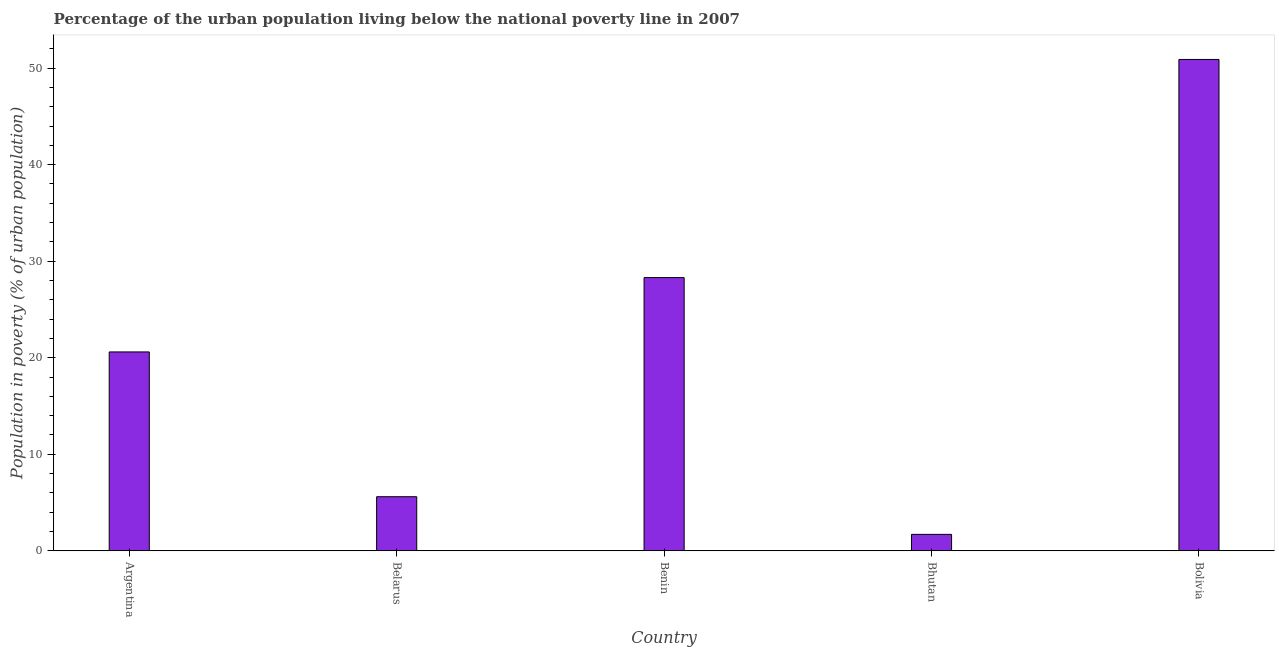What is the title of the graph?
Ensure brevity in your answer.  Percentage of the urban population living below the national poverty line in 2007. What is the label or title of the Y-axis?
Your response must be concise. Population in poverty (% of urban population). Across all countries, what is the maximum percentage of urban population living below poverty line?
Your answer should be very brief. 50.9. Across all countries, what is the minimum percentage of urban population living below poverty line?
Keep it short and to the point. 1.7. In which country was the percentage of urban population living below poverty line minimum?
Offer a terse response. Bhutan. What is the sum of the percentage of urban population living below poverty line?
Offer a very short reply. 107.1. What is the average percentage of urban population living below poverty line per country?
Make the answer very short. 21.42. What is the median percentage of urban population living below poverty line?
Make the answer very short. 20.6. What is the ratio of the percentage of urban population living below poverty line in Bhutan to that in Bolivia?
Offer a very short reply. 0.03. Is the percentage of urban population living below poverty line in Belarus less than that in Benin?
Make the answer very short. Yes. What is the difference between the highest and the second highest percentage of urban population living below poverty line?
Make the answer very short. 22.6. Is the sum of the percentage of urban population living below poverty line in Benin and Bhutan greater than the maximum percentage of urban population living below poverty line across all countries?
Your response must be concise. No. What is the difference between the highest and the lowest percentage of urban population living below poverty line?
Your answer should be very brief. 49.2. How many bars are there?
Your response must be concise. 5. Are all the bars in the graph horizontal?
Your answer should be very brief. No. What is the difference between two consecutive major ticks on the Y-axis?
Your response must be concise. 10. What is the Population in poverty (% of urban population) in Argentina?
Make the answer very short. 20.6. What is the Population in poverty (% of urban population) of Belarus?
Offer a very short reply. 5.6. What is the Population in poverty (% of urban population) of Benin?
Provide a succinct answer. 28.3. What is the Population in poverty (% of urban population) in Bolivia?
Your answer should be compact. 50.9. What is the difference between the Population in poverty (% of urban population) in Argentina and Belarus?
Your answer should be compact. 15. What is the difference between the Population in poverty (% of urban population) in Argentina and Bolivia?
Your answer should be very brief. -30.3. What is the difference between the Population in poverty (% of urban population) in Belarus and Benin?
Give a very brief answer. -22.7. What is the difference between the Population in poverty (% of urban population) in Belarus and Bhutan?
Ensure brevity in your answer.  3.9. What is the difference between the Population in poverty (% of urban population) in Belarus and Bolivia?
Provide a short and direct response. -45.3. What is the difference between the Population in poverty (% of urban population) in Benin and Bhutan?
Your response must be concise. 26.6. What is the difference between the Population in poverty (% of urban population) in Benin and Bolivia?
Offer a terse response. -22.6. What is the difference between the Population in poverty (% of urban population) in Bhutan and Bolivia?
Your answer should be very brief. -49.2. What is the ratio of the Population in poverty (% of urban population) in Argentina to that in Belarus?
Your response must be concise. 3.68. What is the ratio of the Population in poverty (% of urban population) in Argentina to that in Benin?
Ensure brevity in your answer.  0.73. What is the ratio of the Population in poverty (% of urban population) in Argentina to that in Bhutan?
Offer a terse response. 12.12. What is the ratio of the Population in poverty (% of urban population) in Argentina to that in Bolivia?
Your answer should be compact. 0.41. What is the ratio of the Population in poverty (% of urban population) in Belarus to that in Benin?
Provide a succinct answer. 0.2. What is the ratio of the Population in poverty (% of urban population) in Belarus to that in Bhutan?
Give a very brief answer. 3.29. What is the ratio of the Population in poverty (% of urban population) in Belarus to that in Bolivia?
Your answer should be compact. 0.11. What is the ratio of the Population in poverty (% of urban population) in Benin to that in Bhutan?
Provide a succinct answer. 16.65. What is the ratio of the Population in poverty (% of urban population) in Benin to that in Bolivia?
Give a very brief answer. 0.56. What is the ratio of the Population in poverty (% of urban population) in Bhutan to that in Bolivia?
Your answer should be very brief. 0.03. 